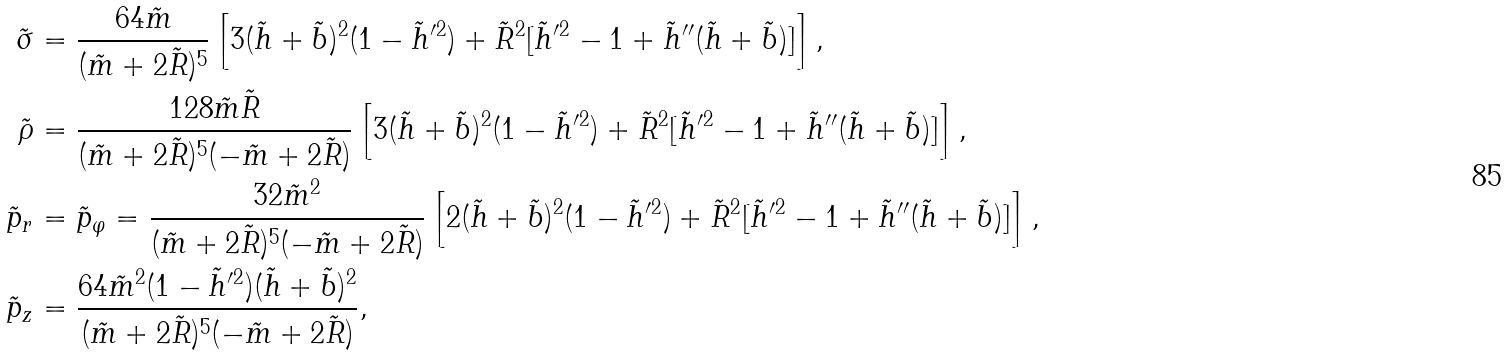<formula> <loc_0><loc_0><loc_500><loc_500>\tilde { \sigma } & = \frac { 6 4 \tilde { m } } { ( \tilde { m } + 2 \tilde { R } ) ^ { 5 } } \left [ 3 ( \tilde { h } + \tilde { b } ) ^ { 2 } ( 1 - \tilde { h } ^ { \prime 2 } ) + \tilde { R } ^ { 2 } [ \tilde { h } ^ { \prime 2 } - 1 + \tilde { h } ^ { \prime \prime } ( \tilde { h } + \tilde { b } ) ] \right ] , \\ \tilde { \rho } & = \frac { 1 2 8 \tilde { m } \tilde { R } } { ( \tilde { m } + 2 \tilde { R } ) ^ { 5 } ( - \tilde { m } + 2 \tilde { R } ) } \left [ 3 ( \tilde { h } + \tilde { b } ) ^ { 2 } ( 1 - \tilde { h } ^ { \prime 2 } ) + \tilde { R } ^ { 2 } [ \tilde { h } ^ { \prime 2 } - 1 + \tilde { h } ^ { \prime \prime } ( \tilde { h } + \tilde { b } ) ] \right ] , \\ \tilde { p } _ { r } & = \tilde { p } _ { \varphi } = \frac { 3 2 \tilde { m } ^ { 2 } } { ( \tilde { m } + 2 \tilde { R } ) ^ { 5 } ( - \tilde { m } + 2 \tilde { R } ) } \left [ 2 ( \tilde { h } + \tilde { b } ) ^ { 2 } ( 1 - \tilde { h } ^ { \prime 2 } ) + \tilde { R } ^ { 2 } [ \tilde { h } ^ { \prime 2 } - 1 + \tilde { h } ^ { \prime \prime } ( \tilde { h } + \tilde { b } ) ] \right ] , \\ \tilde { p } _ { z } & = \frac { 6 4 \tilde { m } ^ { 2 } ( 1 - \tilde { h } ^ { \prime 2 } ) ( \tilde { h } + \tilde { b } ) ^ { 2 } } { ( \tilde { m } + 2 \tilde { R } ) ^ { 5 } ( - \tilde { m } + 2 \tilde { R } ) } ,</formula> 